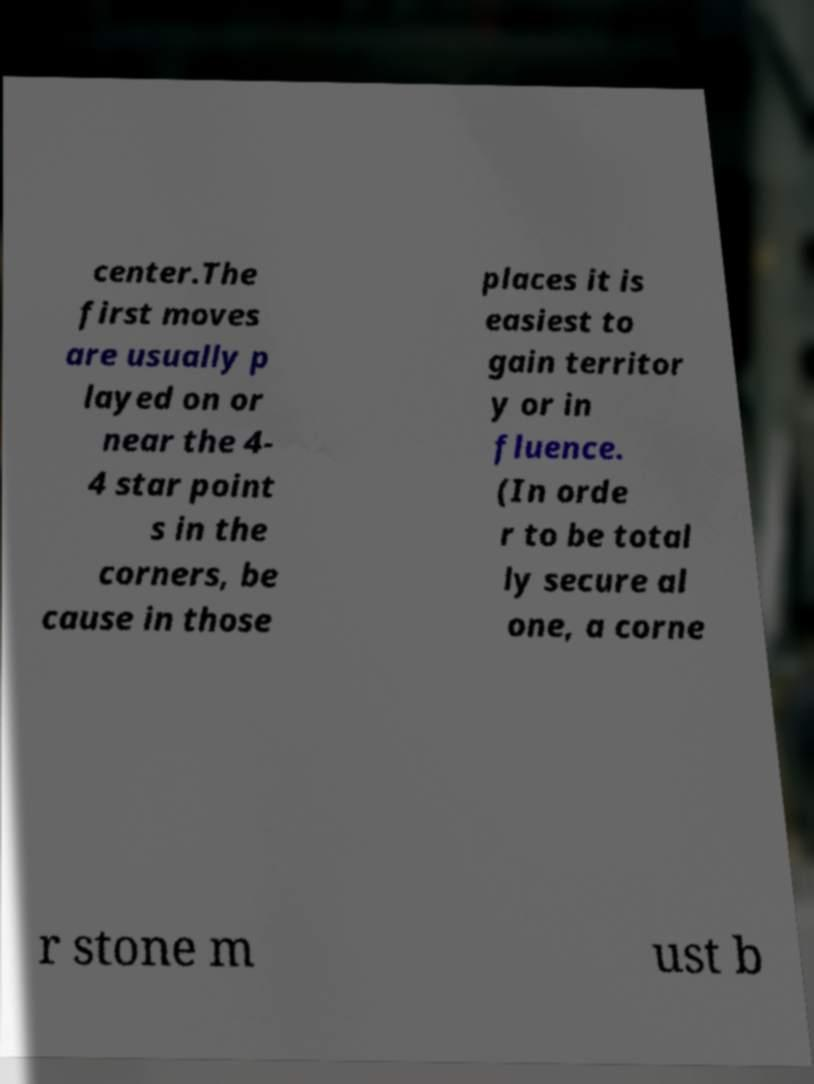Could you extract and type out the text from this image? center.The first moves are usually p layed on or near the 4- 4 star point s in the corners, be cause in those places it is easiest to gain territor y or in fluence. (In orde r to be total ly secure al one, a corne r stone m ust b 